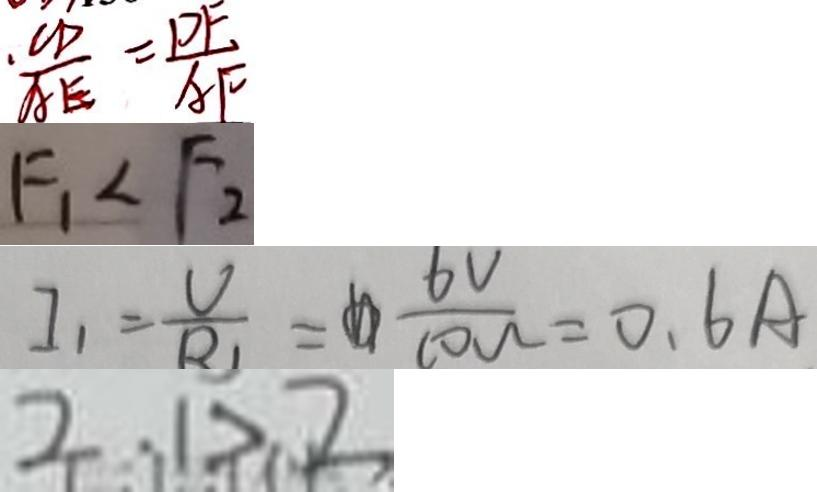Convert formula to latex. <formula><loc_0><loc_0><loc_500><loc_500>. \frac { C D } { A E } = \frac { D F } { A F } 
 F _ { 1 } < F _ { 2 } 
 I _ { 1 } = \frac { V } { R } _ { 1 } = \frac { 6 V } { 1 0 w } = 0 . 6 A 
 2 . 1 > 2</formula> 